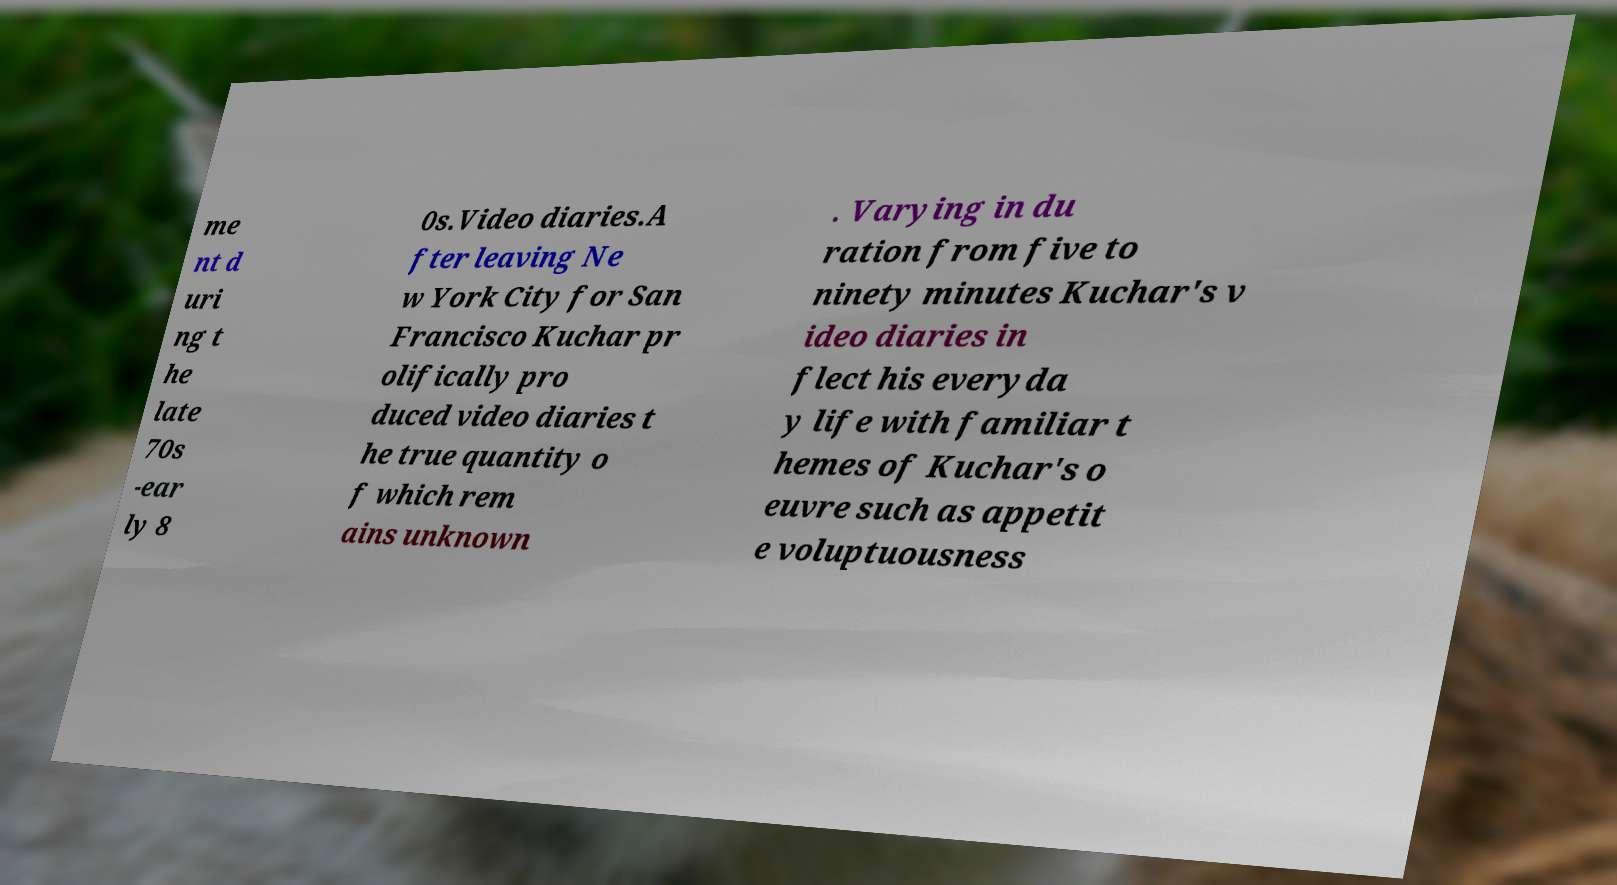Please identify and transcribe the text found in this image. me nt d uri ng t he late 70s -ear ly 8 0s.Video diaries.A fter leaving Ne w York City for San Francisco Kuchar pr olifically pro duced video diaries t he true quantity o f which rem ains unknown . Varying in du ration from five to ninety minutes Kuchar's v ideo diaries in flect his everyda y life with familiar t hemes of Kuchar's o euvre such as appetit e voluptuousness 